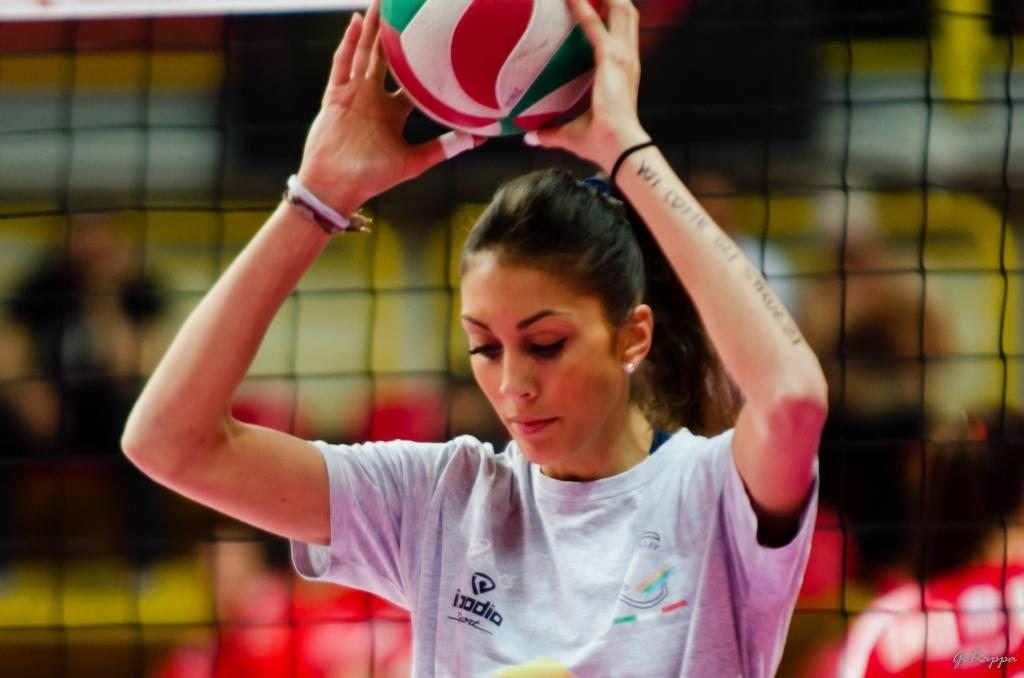Who is the main subject in the image? There is a woman in the image. What is the woman holding in her hands? The woman is holding a ball in her hands. Can you describe any other objects or features in the image? There is a mesh in the image. How would you describe the background of the image? The background of the image is blurred. What type of rhythm is the woman playing in the image? There is no indication of rhythm or music in the image; the woman is simply holding a ball. 